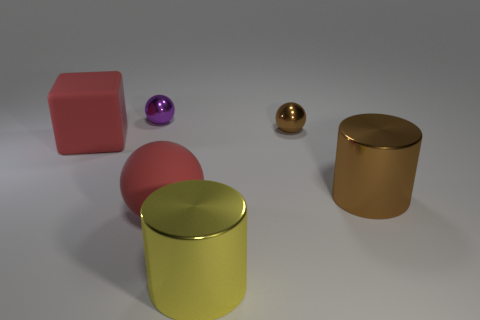There is a rubber object right of the purple thing; does it have the same color as the rubber cube?
Ensure brevity in your answer.  Yes. Is the number of yellow things to the right of the big yellow cylinder less than the number of large cyan shiny objects?
Your response must be concise. No. What is the color of the big object that is made of the same material as the brown cylinder?
Give a very brief answer. Yellow. There is a red rubber object in front of the big red rubber cube; what size is it?
Give a very brief answer. Large. Do the purple thing and the large yellow thing have the same material?
Provide a short and direct response. Yes. There is a red rubber object to the right of the matte object to the left of the rubber sphere; is there a metal object right of it?
Your answer should be very brief. Yes. The rubber ball has what color?
Your response must be concise. Red. There is a sphere that is the same size as the cube; what is its color?
Make the answer very short. Red. There is a tiny shiny thing that is right of the matte ball; is its shape the same as the purple metallic thing?
Ensure brevity in your answer.  Yes. There is a big shiny cylinder that is on the right side of the metal sphere on the right side of the big matte object in front of the brown cylinder; what is its color?
Offer a very short reply. Brown. 